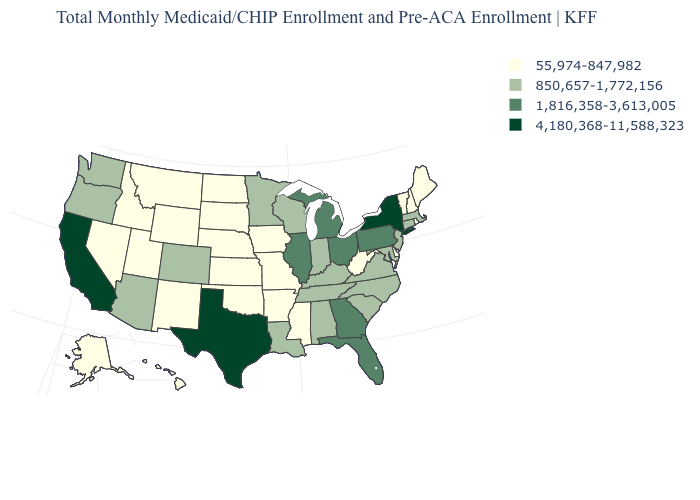What is the lowest value in the USA?
Quick response, please. 55,974-847,982. What is the value of West Virginia?
Give a very brief answer. 55,974-847,982. Which states hav the highest value in the West?
Quick response, please. California. What is the lowest value in the MidWest?
Write a very short answer. 55,974-847,982. What is the value of Pennsylvania?
Answer briefly. 1,816,358-3,613,005. Name the states that have a value in the range 55,974-847,982?
Keep it brief. Alaska, Arkansas, Delaware, Hawaii, Idaho, Iowa, Kansas, Maine, Mississippi, Missouri, Montana, Nebraska, Nevada, New Hampshire, New Mexico, North Dakota, Oklahoma, Rhode Island, South Dakota, Utah, Vermont, West Virginia, Wyoming. What is the value of West Virginia?
Give a very brief answer. 55,974-847,982. What is the lowest value in states that border South Dakota?
Quick response, please. 55,974-847,982. Which states hav the highest value in the South?
Keep it brief. Texas. What is the lowest value in states that border Maryland?
Write a very short answer. 55,974-847,982. What is the value of Arkansas?
Answer briefly. 55,974-847,982. What is the highest value in states that border Nevada?
Keep it brief. 4,180,368-11,588,323. What is the highest value in the MidWest ?
Concise answer only. 1,816,358-3,613,005. Among the states that border Kentucky , does Ohio have the highest value?
Keep it brief. Yes. Name the states that have a value in the range 55,974-847,982?
Quick response, please. Alaska, Arkansas, Delaware, Hawaii, Idaho, Iowa, Kansas, Maine, Mississippi, Missouri, Montana, Nebraska, Nevada, New Hampshire, New Mexico, North Dakota, Oklahoma, Rhode Island, South Dakota, Utah, Vermont, West Virginia, Wyoming. 